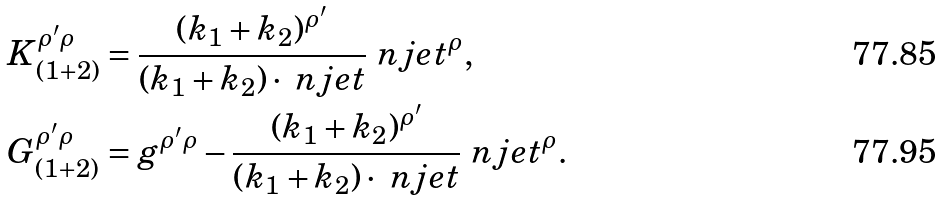Convert formula to latex. <formula><loc_0><loc_0><loc_500><loc_500>K _ { ( 1 + 2 ) } ^ { \rho ^ { \prime } \rho } & = \frac { ( k _ { 1 } + k _ { 2 } ) ^ { \rho ^ { \prime } } } { ( k _ { 1 } + k _ { 2 } ) \cdot \ n j e t } \ n j e t ^ { \rho } , \\ G _ { ( 1 + 2 ) } ^ { \rho ^ { \prime } \rho } & = g ^ { \rho ^ { \prime } \rho } - \frac { ( k _ { 1 } + k _ { 2 } ) ^ { \rho ^ { \prime } } } { ( k _ { 1 } + k _ { 2 } ) \cdot \ n j e t } \ n j e t ^ { \rho } .</formula> 